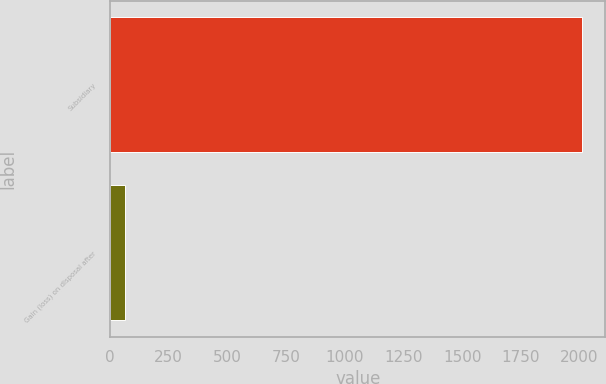Convert chart. <chart><loc_0><loc_0><loc_500><loc_500><bar_chart><fcel>Subsidiary<fcel>Gain (loss) on disposal after<nl><fcel>2010<fcel>64<nl></chart> 